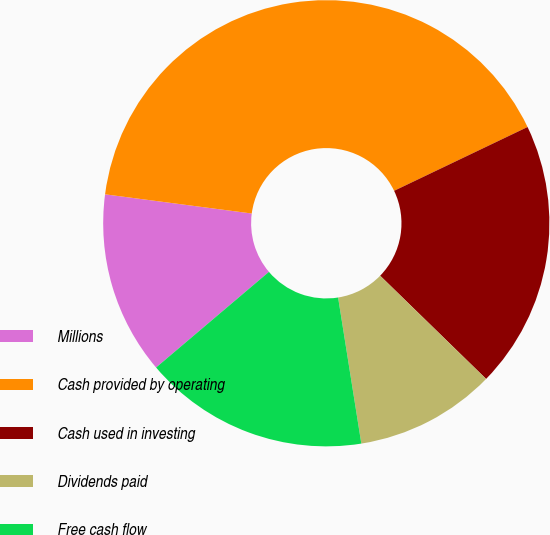<chart> <loc_0><loc_0><loc_500><loc_500><pie_chart><fcel>Millions<fcel>Cash provided by operating<fcel>Cash used in investing<fcel>Dividends paid<fcel>Free cash flow<nl><fcel>13.26%<fcel>40.83%<fcel>19.39%<fcel>10.2%<fcel>16.32%<nl></chart> 